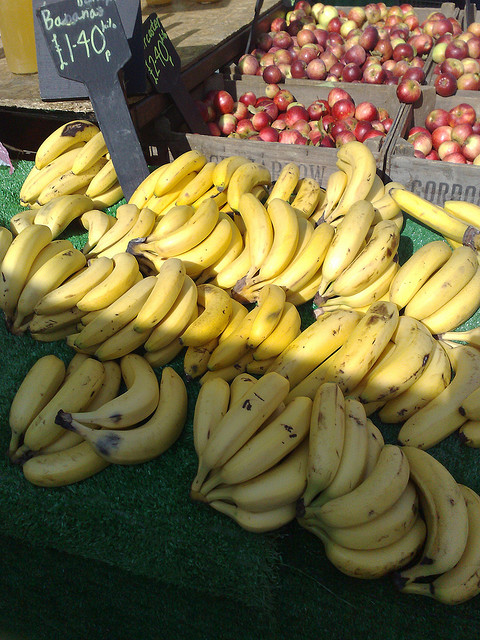What could be the price per pound for these bananas? While the image doesn't provide enough information to determine the exact price per pound, the sign next to the bananas suggests they have a set price which can vary based on the market and location. Typically, bananas can range from $0.30 to $0.60 per pound. Is there a particular time of year that bananas are more readily available? Bananas are generally available year-round as they are grown in tropical climates around the world. However, their price and availability may fluctuate due to seasonal demand, weather conditions, and factors affecting international trade routes. 